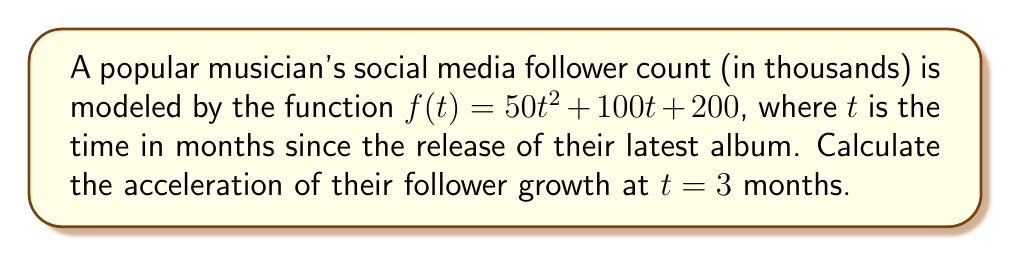Show me your answer to this math problem. To find the acceleration of follower growth, we need to calculate the second derivative of the given function.

Step 1: Find the first derivative (velocity of follower growth)
The first derivative represents the rate of change of followers over time.
$$f'(t) = \frac{d}{dt}(50t^2 + 100t + 200) = 100t + 100$$

Step 2: Find the second derivative (acceleration of follower growth)
The second derivative represents the rate of change of the velocity, which is the acceleration.
$$f''(t) = \frac{d}{dt}(100t + 100) = 100$$

Step 3: Evaluate the second derivative at $t = 3$
Since the second derivative is a constant, the acceleration is the same at all times, including at $t = 3$.
$$f''(3) = 100$$

Therefore, the acceleration of the musician's follower growth is 100 thousand followers per month squared.
Answer: 100 